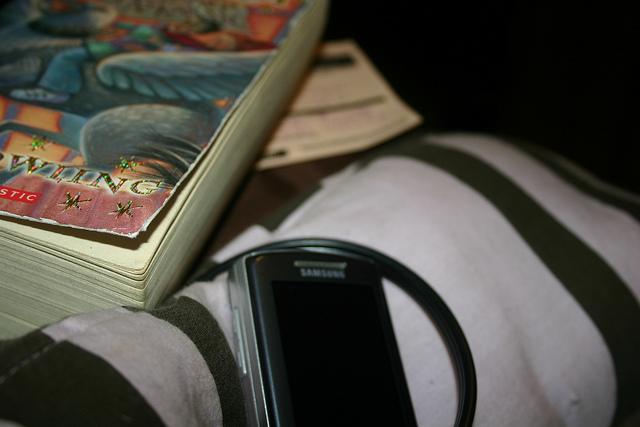What series is the book from?
Write a very short answer. Harry potter. What brand is the electronic device?
Keep it brief. Samsung. What is the phone resting on?
Concise answer only. Pillow. Is the book on a bed?
Keep it brief. Yes. 